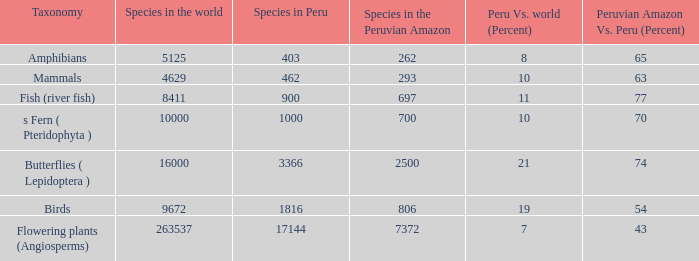What's the minimum species in the peruvian amazon with peru vs. world (percent) value of 7 7372.0. 